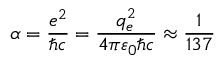Convert formula to latex. <formula><loc_0><loc_0><loc_500><loc_500>\alpha = { \frac { e ^ { 2 } } { \hbar { c } } } = { \frac { q _ { e } ^ { 2 } } { 4 \pi \varepsilon _ { 0 } \hbar { c } } } \approx { \frac { 1 } { 1 3 7 } }</formula> 